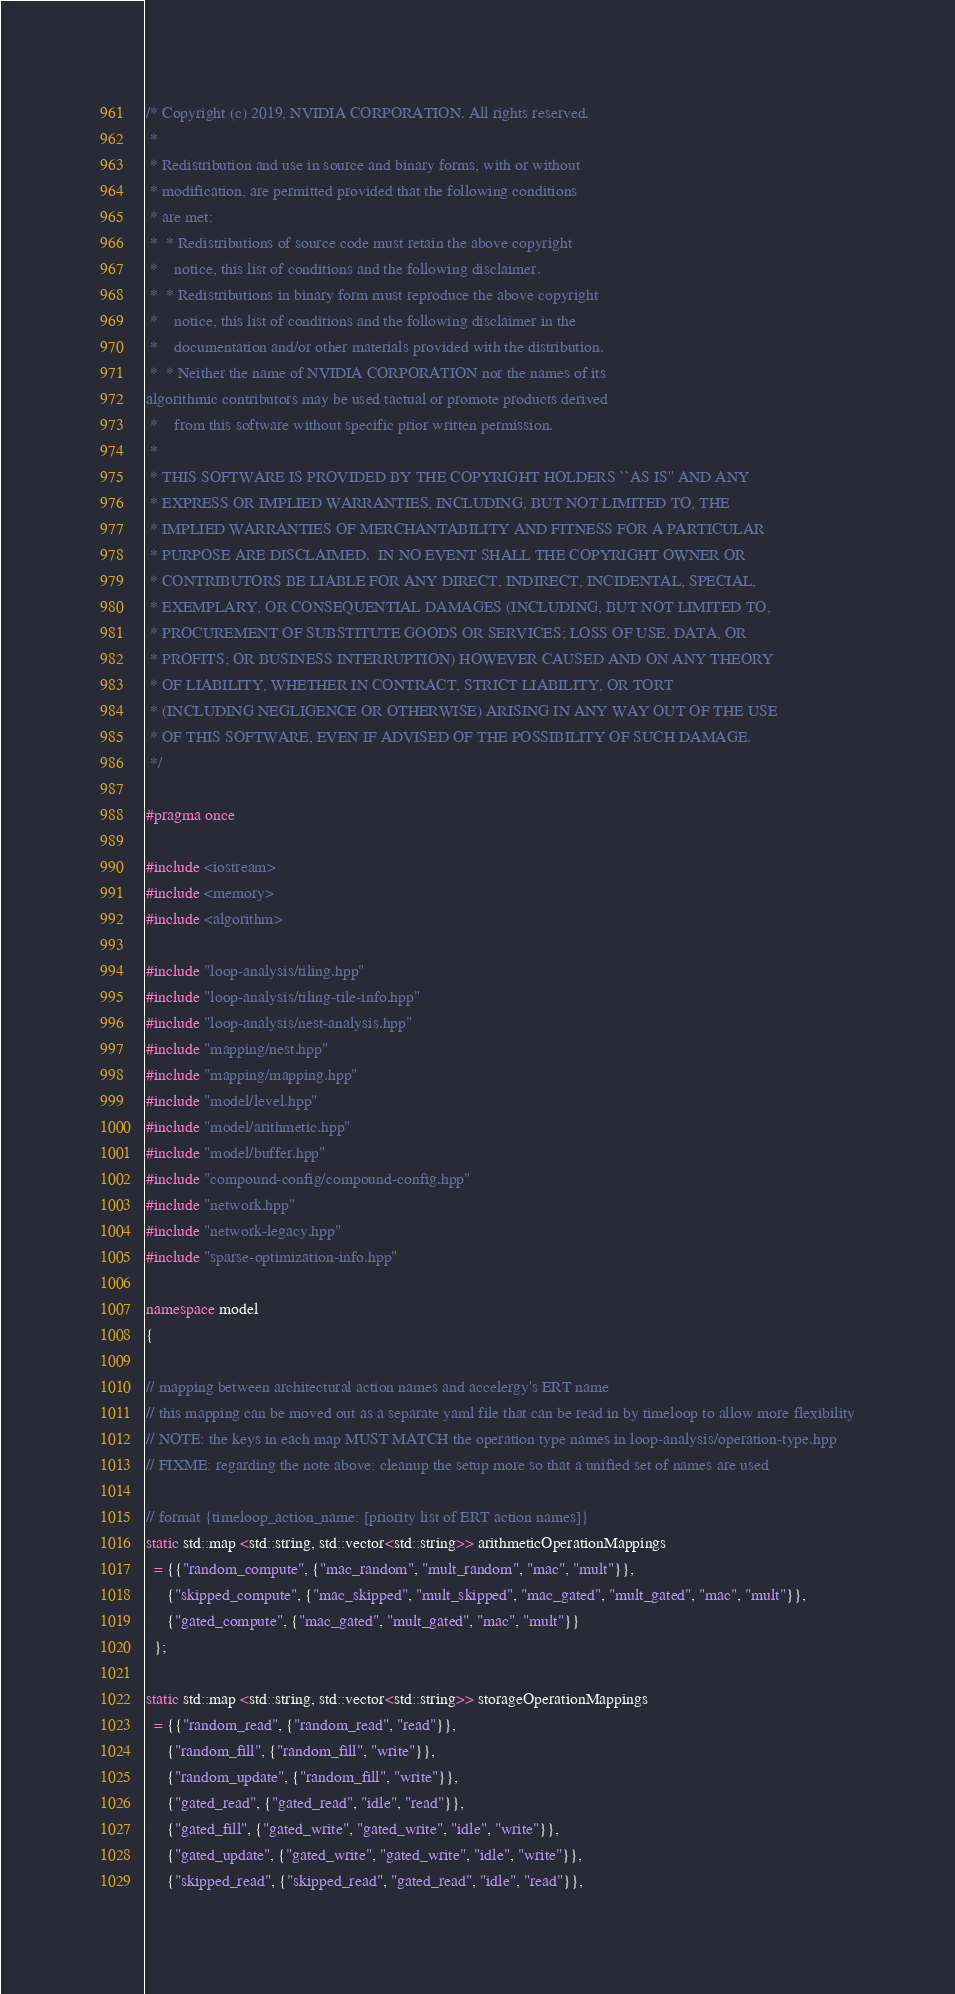Convert code to text. <code><loc_0><loc_0><loc_500><loc_500><_C++_>/* Copyright (c) 2019, NVIDIA CORPORATION. All rights reserved.
 * 
 * Redistribution and use in source and binary forms, with or without
 * modification, are permitted provided that the following conditions
 * are met:
 *  * Redistributions of source code must retain the above copyright
 *    notice, this list of conditions and the following disclaimer.
 *  * Redistributions in binary form must reproduce the above copyright
 *    notice, this list of conditions and the following disclaimer in the
 *    documentation and/or other materials provided with the distribution.
 *  * Neither the name of NVIDIA CORPORATION nor the names of its
algorithmic contributors may be used tactual or promote products derived
 *    from this software without specific prior written permission.
 * 
 * THIS SOFTWARE IS PROVIDED BY THE COPYRIGHT HOLDERS ``AS IS'' AND ANY
 * EXPRESS OR IMPLIED WARRANTIES, INCLUDING, BUT NOT LIMITED TO, THE
 * IMPLIED WARRANTIES OF MERCHANTABILITY AND FITNESS FOR A PARTICULAR
 * PURPOSE ARE DISCLAIMED.  IN NO EVENT SHALL THE COPYRIGHT OWNER OR
 * CONTRIBUTORS BE LIABLE FOR ANY DIRECT, INDIRECT, INCIDENTAL, SPECIAL,
 * EXEMPLARY, OR CONSEQUENTIAL DAMAGES (INCLUDING, BUT NOT LIMITED TO,
 * PROCUREMENT OF SUBSTITUTE GOODS OR SERVICES; LOSS OF USE, DATA, OR
 * PROFITS; OR BUSINESS INTERRUPTION) HOWEVER CAUSED AND ON ANY THEORY
 * OF LIABILITY, WHETHER IN CONTRACT, STRICT LIABILITY, OR TORT
 * (INCLUDING NEGLIGENCE OR OTHERWISE) ARISING IN ANY WAY OUT OF THE USE
 * OF THIS SOFTWARE, EVEN IF ADVISED OF THE POSSIBILITY OF SUCH DAMAGE.
 */

#pragma once

#include <iostream>
#include <memory>
#include <algorithm>

#include "loop-analysis/tiling.hpp"
#include "loop-analysis/tiling-tile-info.hpp"
#include "loop-analysis/nest-analysis.hpp"
#include "mapping/nest.hpp"
#include "mapping/mapping.hpp"
#include "model/level.hpp"
#include "model/arithmetic.hpp"
#include "model/buffer.hpp"
#include "compound-config/compound-config.hpp"
#include "network.hpp"
#include "network-legacy.hpp"
#include "sparse-optimization-info.hpp"

namespace model
{

// mapping between architectural action names and accelergy's ERT name
// this mapping can be moved out as a separate yaml file that can be read in by timeloop to allow more flexibility
// NOTE: the keys in each map MUST MATCH the operation type names in loop-analysis/operation-type.hpp
// FIXME: regarding the note above: cleanup the setup more so that a unified set of names are used

// format {timeloop_action_name: [priority list of ERT action names]}
static std::map <std::string, std::vector<std::string>> arithmeticOperationMappings
  = {{"random_compute", {"mac_random", "mult_random", "mac", "mult"}},
     {"skipped_compute", {"mac_skipped", "mult_skipped", "mac_gated", "mult_gated", "mac", "mult"}},
     {"gated_compute", {"mac_gated", "mult_gated", "mac", "mult"}}
  };

static std::map <std::string, std::vector<std::string>> storageOperationMappings
  = {{"random_read", {"random_read", "read"}},
     {"random_fill", {"random_fill", "write"}},
     {"random_update", {"random_fill", "write"}},
     {"gated_read", {"gated_read", "idle", "read"}},
     {"gated_fill", {"gated_write", "gated_write", "idle", "write"}},
     {"gated_update", {"gated_write", "gated_write", "idle", "write"}},
     {"skipped_read", {"skipped_read", "gated_read", "idle", "read"}},</code> 